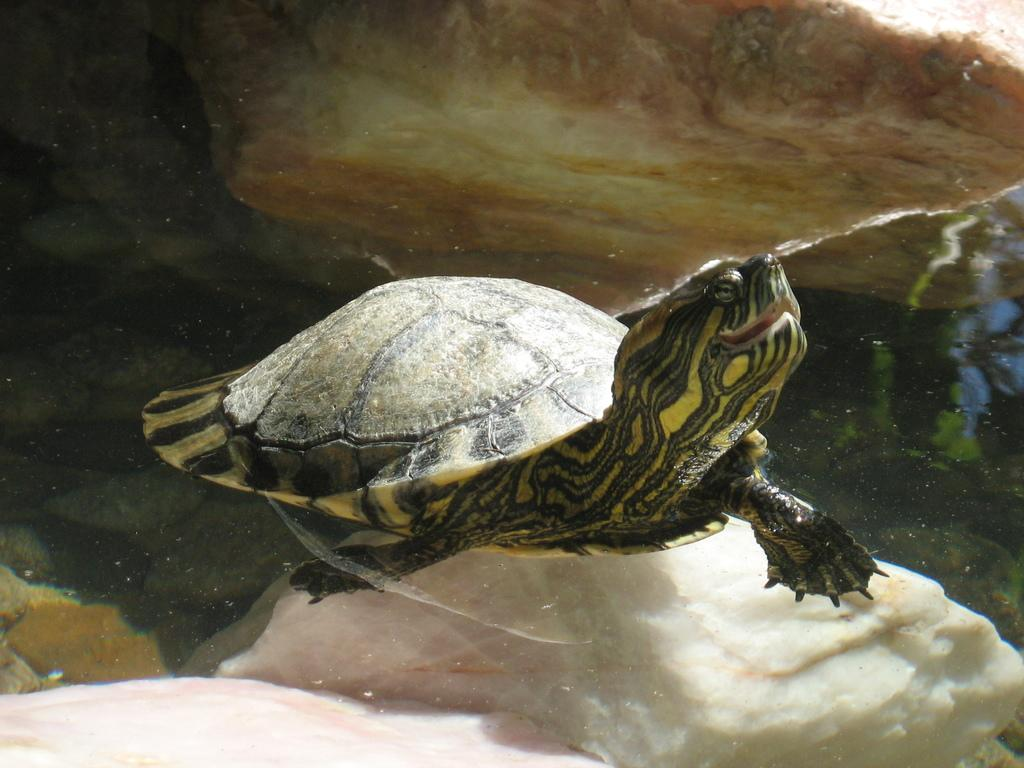What animal can be seen in the picture? There is a turtle in the picture. What is at the bottom of the picture? There is water at the bottom of the picture. What other object is present in the picture? There is a stone in the picture. What type of laborer is working in the picture? There is no laborer present in the picture; it features a turtle, water, and a stone. 